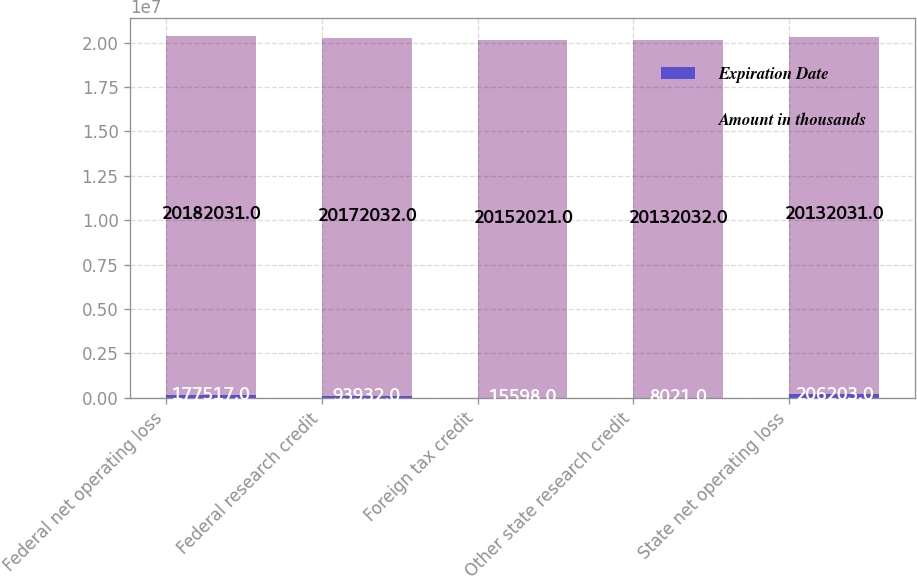<chart> <loc_0><loc_0><loc_500><loc_500><stacked_bar_chart><ecel><fcel>Federal net operating loss<fcel>Federal research credit<fcel>Foreign tax credit<fcel>Other state research credit<fcel>State net operating loss<nl><fcel>Expiration Date<fcel>177517<fcel>93932<fcel>15598<fcel>8021<fcel>206203<nl><fcel>Amount in thousands<fcel>2.0182e+07<fcel>2.0172e+07<fcel>2.0152e+07<fcel>2.0132e+07<fcel>2.0132e+07<nl></chart> 